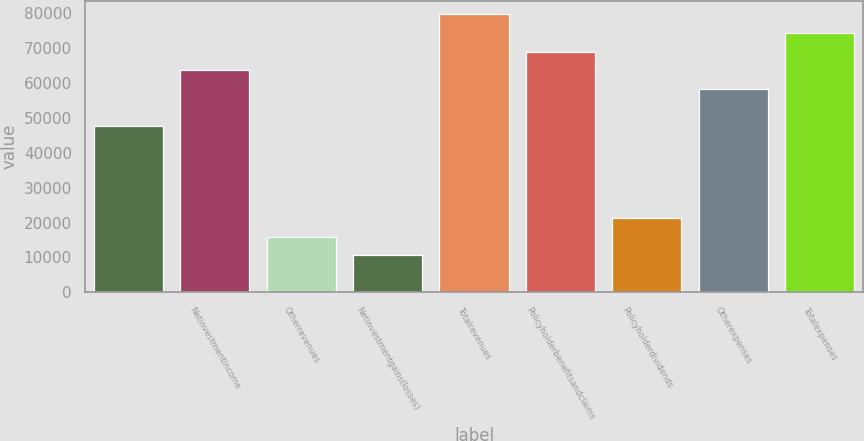<chart> <loc_0><loc_0><loc_500><loc_500><bar_chart><ecel><fcel>Netinvestmentincome<fcel>Otherrevenues<fcel>Netinvestmentgains(losses)<fcel>Totalrevenues<fcel>Policyholderbenefitsandclaims<fcel>Policyholderdividends<fcel>Otherexpenses<fcel>Totalexpenses<nl><fcel>47710<fcel>63601<fcel>15928<fcel>10631<fcel>79492<fcel>68898<fcel>21225<fcel>58304<fcel>74195<nl></chart> 